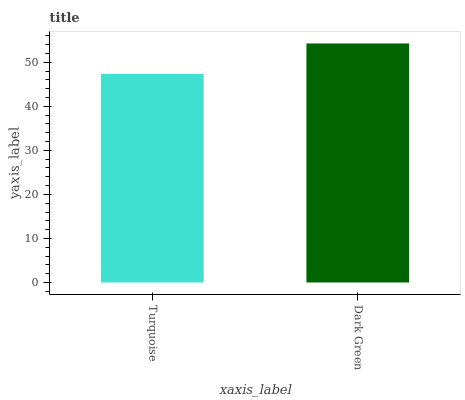Is Turquoise the minimum?
Answer yes or no. Yes. Is Dark Green the maximum?
Answer yes or no. Yes. Is Dark Green the minimum?
Answer yes or no. No. Is Dark Green greater than Turquoise?
Answer yes or no. Yes. Is Turquoise less than Dark Green?
Answer yes or no. Yes. Is Turquoise greater than Dark Green?
Answer yes or no. No. Is Dark Green less than Turquoise?
Answer yes or no. No. Is Dark Green the high median?
Answer yes or no. Yes. Is Turquoise the low median?
Answer yes or no. Yes. Is Turquoise the high median?
Answer yes or no. No. Is Dark Green the low median?
Answer yes or no. No. 